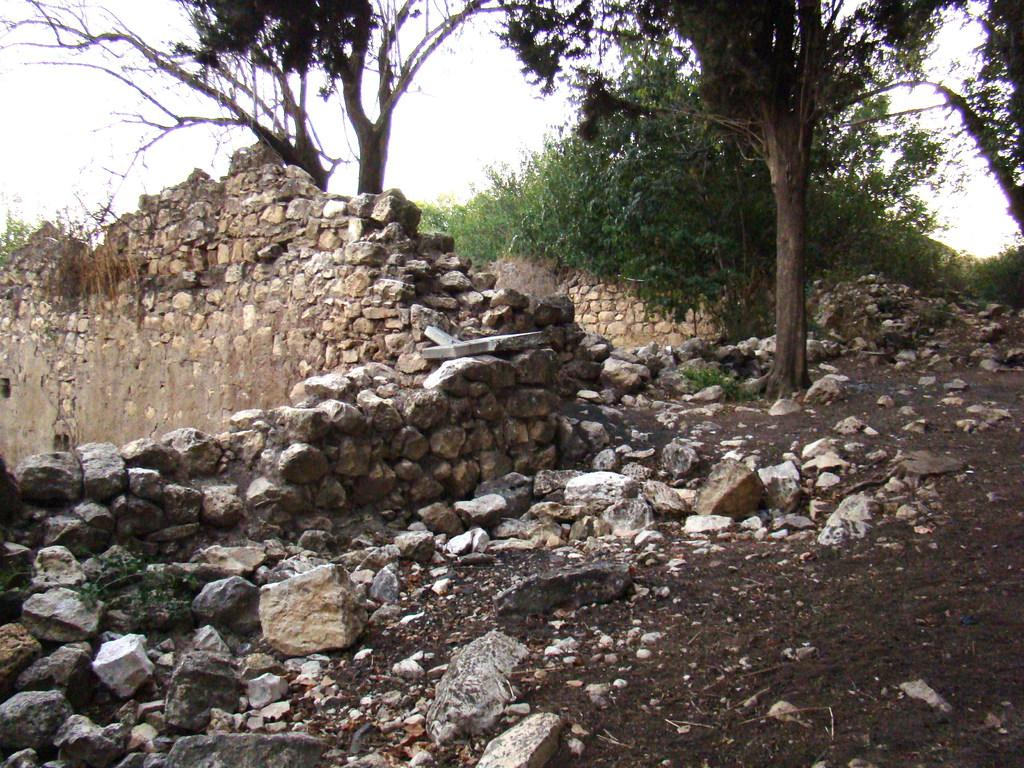What type of natural elements can be seen in the image? There are stones, grass, bushes, and trees in the image. What is the color of the grass in the image? The grass in the image is green. What is visible in the background of the image? The sky is visible in the background of the image. Can you tell me how many sisters are sitting in the boat in the image? There is no boat or sisters present in the image. What type of treatment is being administered to the bushes in the image? There is no treatment being administered to the bushes in the image; they are simply part of the natural landscape. 